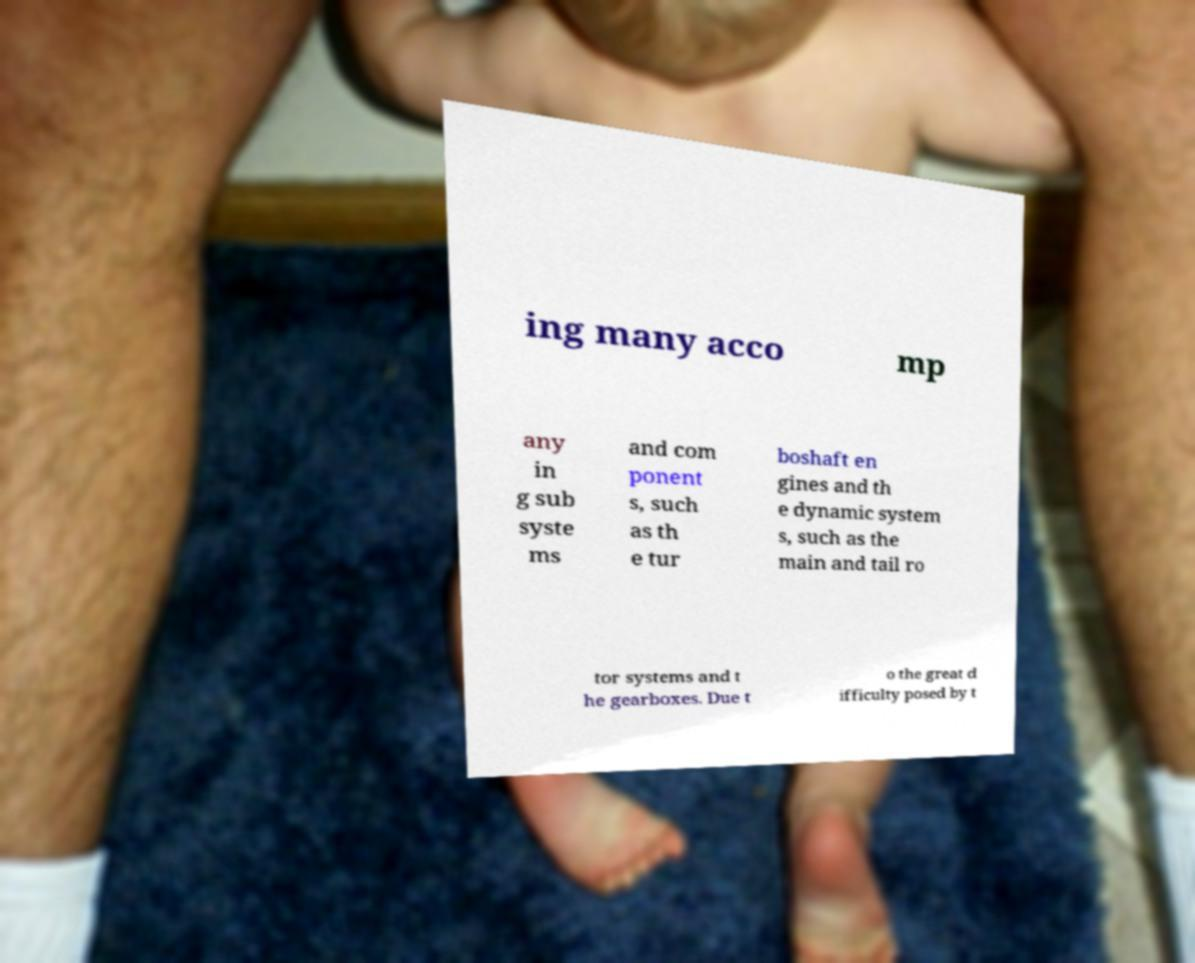Can you read and provide the text displayed in the image?This photo seems to have some interesting text. Can you extract and type it out for me? ing many acco mp any in g sub syste ms and com ponent s, such as th e tur boshaft en gines and th e dynamic system s, such as the main and tail ro tor systems and t he gearboxes. Due t o the great d ifficulty posed by t 